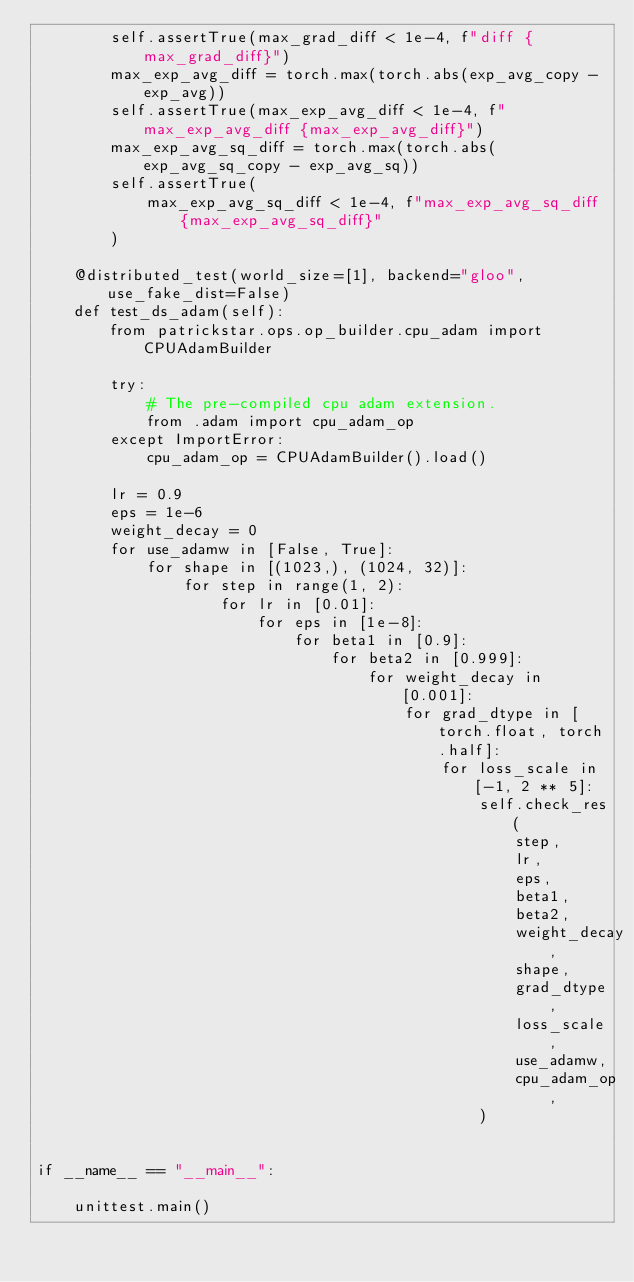Convert code to text. <code><loc_0><loc_0><loc_500><loc_500><_Python_>        self.assertTrue(max_grad_diff < 1e-4, f"diff {max_grad_diff}")
        max_exp_avg_diff = torch.max(torch.abs(exp_avg_copy - exp_avg))
        self.assertTrue(max_exp_avg_diff < 1e-4, f"max_exp_avg_diff {max_exp_avg_diff}")
        max_exp_avg_sq_diff = torch.max(torch.abs(exp_avg_sq_copy - exp_avg_sq))
        self.assertTrue(
            max_exp_avg_sq_diff < 1e-4, f"max_exp_avg_sq_diff {max_exp_avg_sq_diff}"
        )

    @distributed_test(world_size=[1], backend="gloo", use_fake_dist=False)
    def test_ds_adam(self):
        from patrickstar.ops.op_builder.cpu_adam import CPUAdamBuilder

        try:
            # The pre-compiled cpu adam extension.
            from .adam import cpu_adam_op
        except ImportError:
            cpu_adam_op = CPUAdamBuilder().load()

        lr = 0.9
        eps = 1e-6
        weight_decay = 0
        for use_adamw in [False, True]:
            for shape in [(1023,), (1024, 32)]:
                for step in range(1, 2):
                    for lr in [0.01]:
                        for eps in [1e-8]:
                            for beta1 in [0.9]:
                                for beta2 in [0.999]:
                                    for weight_decay in [0.001]:
                                        for grad_dtype in [torch.float, torch.half]:
                                            for loss_scale in [-1, 2 ** 5]:
                                                self.check_res(
                                                    step,
                                                    lr,
                                                    eps,
                                                    beta1,
                                                    beta2,
                                                    weight_decay,
                                                    shape,
                                                    grad_dtype,
                                                    loss_scale,
                                                    use_adamw,
                                                    cpu_adam_op,
                                                )


if __name__ == "__main__":

    unittest.main()
</code> 